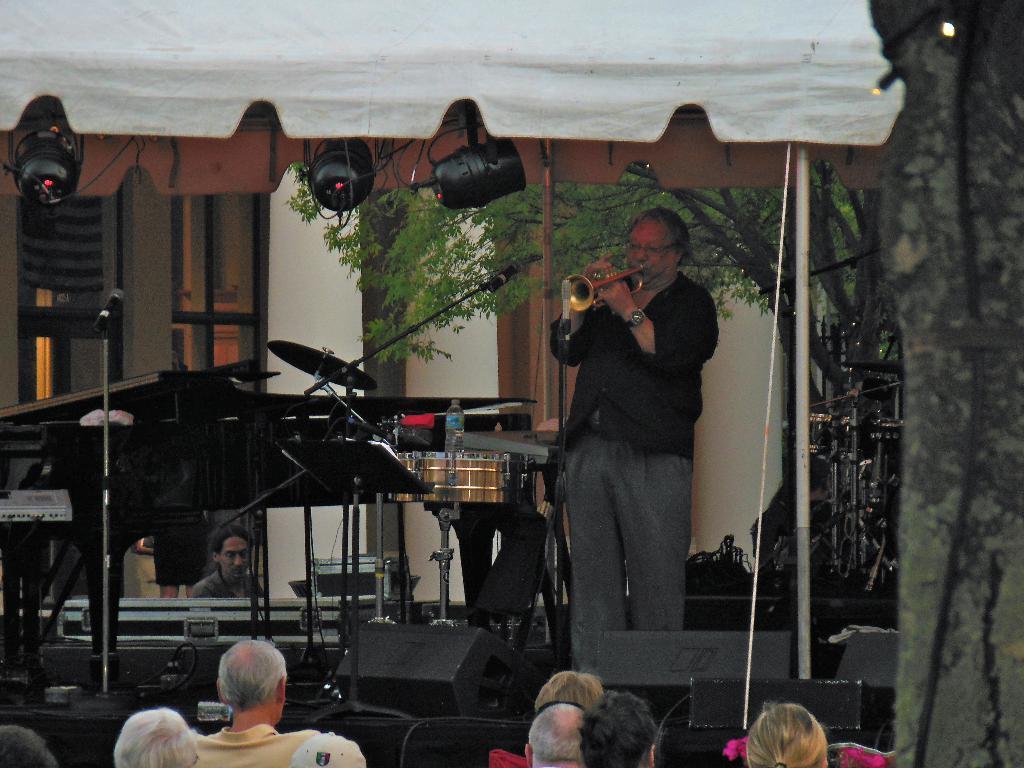Please provide a concise description of this image. In this picture there is a man standing and playing musical instrument and we can see musical instruments, microphones with stands, cables and devices. We can see lights and tent. In the background of the image we can see a person, tree and wall. At the bottom of the image we can see people heads. On the right side of the image we can see tree trunk, wire and lights. 